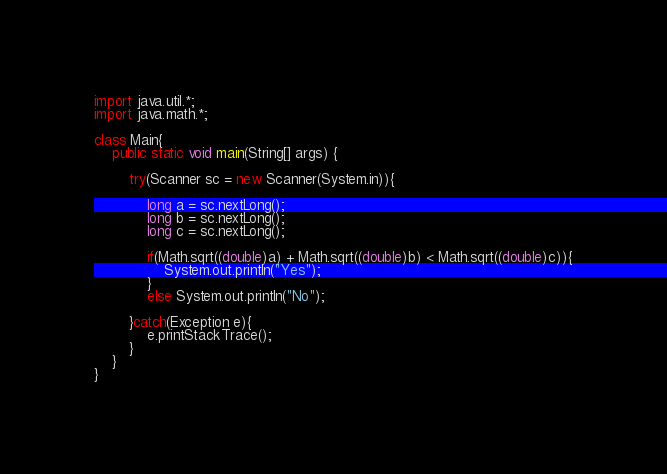Convert code to text. <code><loc_0><loc_0><loc_500><loc_500><_Java_>import java.util.*;
import java.math.*;
         
class Main{
    public static void main(String[] args) {
        
        try(Scanner sc = new Scanner(System.in)){
 
            long a = sc.nextLong();
            long b = sc.nextLong();
            long c = sc.nextLong();

            if(Math.sqrt((double)a) + Math.sqrt((double)b) < Math.sqrt((double)c)){
                System.out.println("Yes");
            } 
            else System.out.println("No");

        }catch(Exception e){
            e.printStackTrace();
        }        
    }
}</code> 